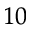Convert formula to latex. <formula><loc_0><loc_0><loc_500><loc_500>^ { 1 0 }</formula> 